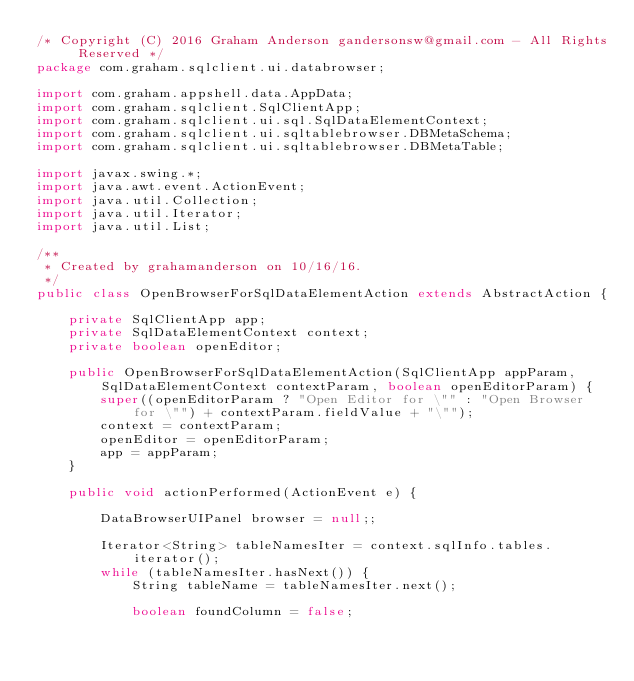Convert code to text. <code><loc_0><loc_0><loc_500><loc_500><_Java_>/* Copyright (C) 2016 Graham Anderson gandersonsw@gmail.com - All Rights Reserved */
package com.graham.sqlclient.ui.databrowser;

import com.graham.appshell.data.AppData;
import com.graham.sqlclient.SqlClientApp;
import com.graham.sqlclient.ui.sql.SqlDataElementContext;
import com.graham.sqlclient.ui.sqltablebrowser.DBMetaSchema;
import com.graham.sqlclient.ui.sqltablebrowser.DBMetaTable;

import javax.swing.*;
import java.awt.event.ActionEvent;
import java.util.Collection;
import java.util.Iterator;
import java.util.List;

/**
 * Created by grahamanderson on 10/16/16.
 */
public class OpenBrowserForSqlDataElementAction extends AbstractAction {

	private SqlClientApp app;
	private SqlDataElementContext context;
	private boolean openEditor;

	public OpenBrowserForSqlDataElementAction(SqlClientApp appParam, SqlDataElementContext contextParam, boolean openEditorParam) {
		super((openEditorParam ? "Open Editor for \"" : "Open Browser for \"") + contextParam.fieldValue + "\"");
		context = contextParam;
		openEditor = openEditorParam;
		app = appParam;
	}

	public void actionPerformed(ActionEvent e) {

		DataBrowserUIPanel browser = null;;

		Iterator<String> tableNamesIter = context.sqlInfo.tables.iterator();
		while (tableNamesIter.hasNext()) {
			String tableName = tableNamesIter.next();

			boolean foundColumn = false;
</code> 